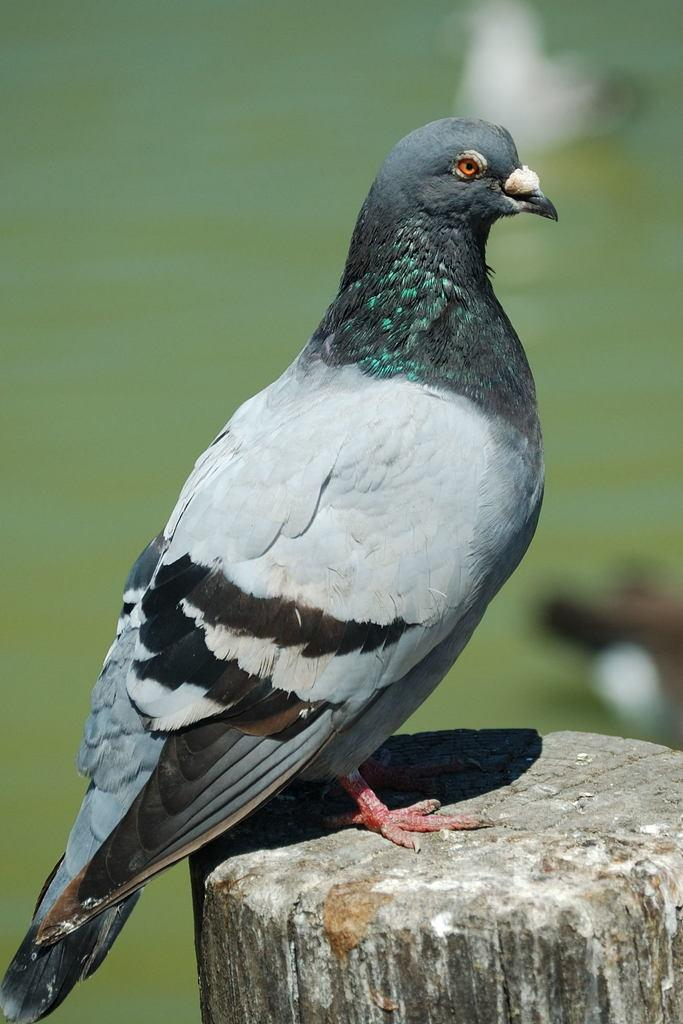What is the main subject of the image? There is a bird in the center of the image. What is the bird standing on? The bird is standing on wood. What can be seen in the background of the image? There is water visible in the background of the image. How many kittens are playing with the girls in the image? There are no kittens or girls present in the image; it features a bird standing on wood with water visible in the background. What type of yak can be seen grazing in the image? There is no yak present in the image; it features a bird standing on wood with water visible in the background. 